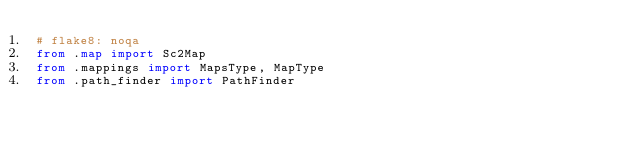Convert code to text. <code><loc_0><loc_0><loc_500><loc_500><_Python_># flake8: noqa
from .map import Sc2Map
from .mappings import MapsType, MapType
from .path_finder import PathFinder
</code> 